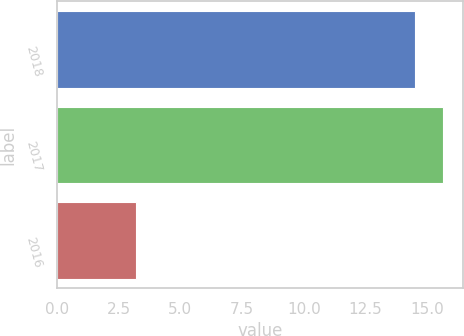Convert chart. <chart><loc_0><loc_0><loc_500><loc_500><bar_chart><fcel>2018<fcel>2017<fcel>2016<nl><fcel>14.5<fcel>15.65<fcel>3.2<nl></chart> 